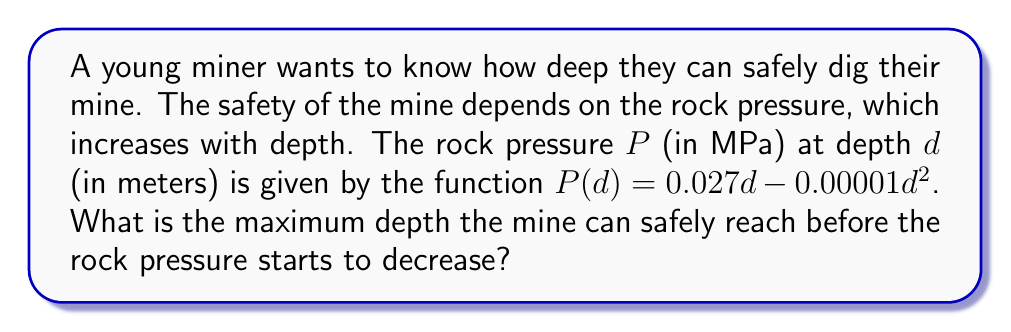Provide a solution to this math problem. To find the maximum depth, we need to determine where the rock pressure function reaches its maximum value. This occurs at the turning point of the quadratic function.

Step 1: Find the derivative of the pressure function.
$$\frac{dP}{dd} = 0.027 - 0.00002d$$

Step 2: Set the derivative equal to zero to find the critical point.
$$0.027 - 0.00002d = 0$$

Step 3: Solve for d.
$$0.00002d = 0.027$$
$$d = \frac{0.027}{0.00002} = 1350$$

Step 4: Verify this is a maximum by checking the second derivative.
$$\frac{d^2P}{dd^2} = -0.00002$$
Since the second derivative is negative, this confirms that d = 1350 is a maximum.

Therefore, the maximum depth the mine can safely reach is 1350 meters.
Answer: 1350 meters 